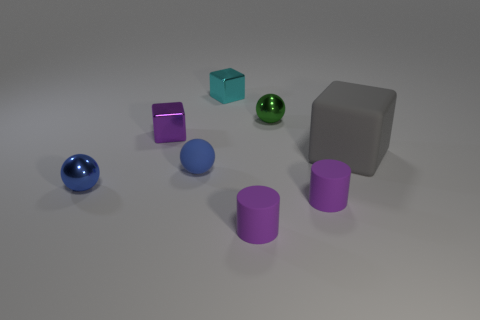Add 2 blue matte balls. How many objects exist? 10 Subtract all cubes. How many objects are left? 5 Add 1 small shiny cubes. How many small shiny cubes exist? 3 Subtract 2 blue balls. How many objects are left? 6 Subtract all large red rubber balls. Subtract all small purple metal blocks. How many objects are left? 7 Add 8 big gray objects. How many big gray objects are left? 9 